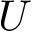<formula> <loc_0><loc_0><loc_500><loc_500>U</formula> 